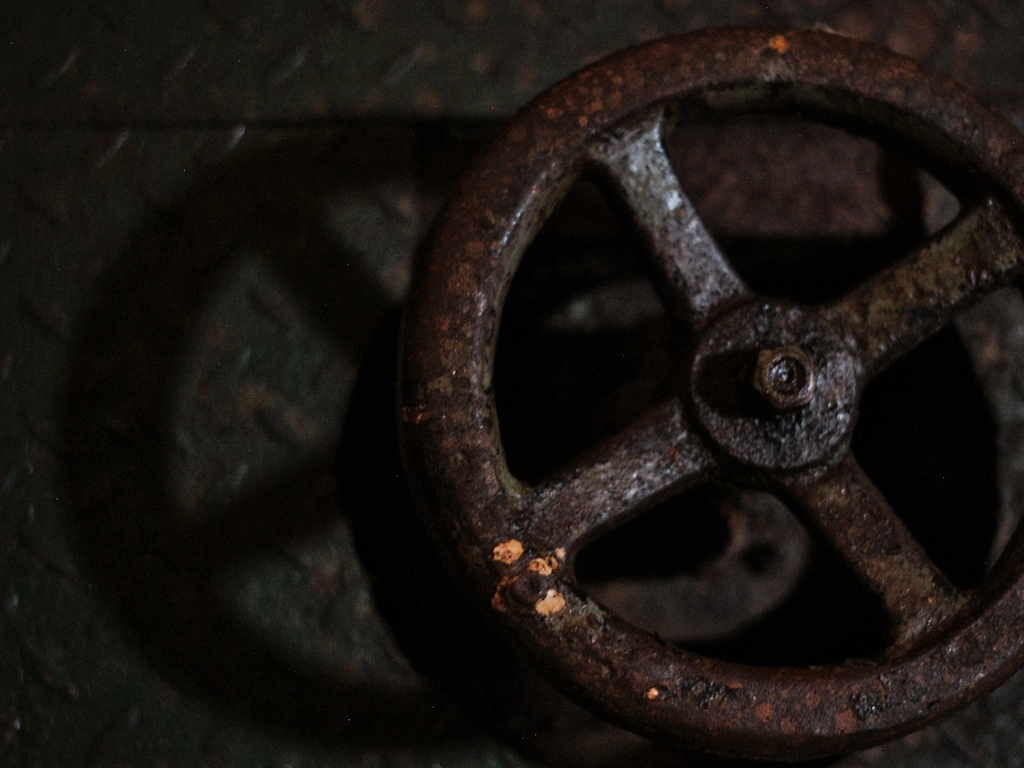Are there any quality issues with this image? Yes, the image appears to be underexposed, resulting in a loss of detail in the shadows. Additionally, the composition is off-center and the focus is not sharp, which may affect the image's clarity and overall aesthetic appeal. 